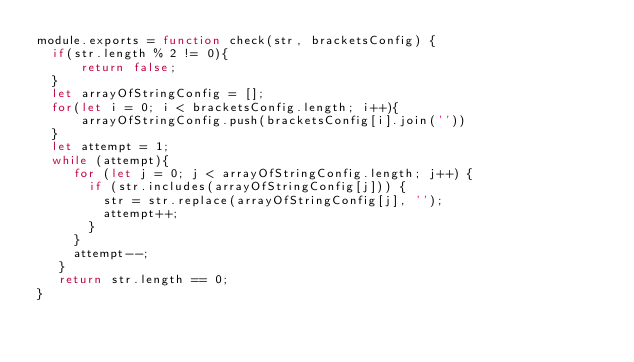Convert code to text. <code><loc_0><loc_0><loc_500><loc_500><_JavaScript_>module.exports = function check(str, bracketsConfig) {
  if(str.length % 2 != 0){
      return false;
  }
  let arrayOfStringConfig = [];
  for(let i = 0; i < bracketsConfig.length; i++){
      arrayOfStringConfig.push(bracketsConfig[i].join(''))
  }
  let attempt = 1;
  while (attempt){
     for (let j = 0; j < arrayOfStringConfig.length; j++) {
       if (str.includes(arrayOfStringConfig[j])) {
         str = str.replace(arrayOfStringConfig[j], '');
         attempt++;
       }
     }
     attempt--;
   }
   return str.length == 0;
}
</code> 